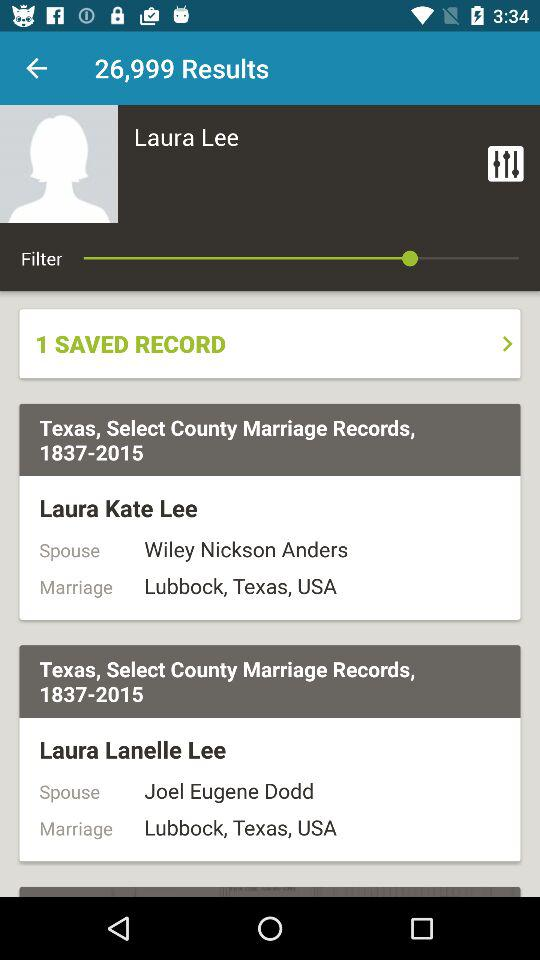How many records are saved? There is 1 saved record. 